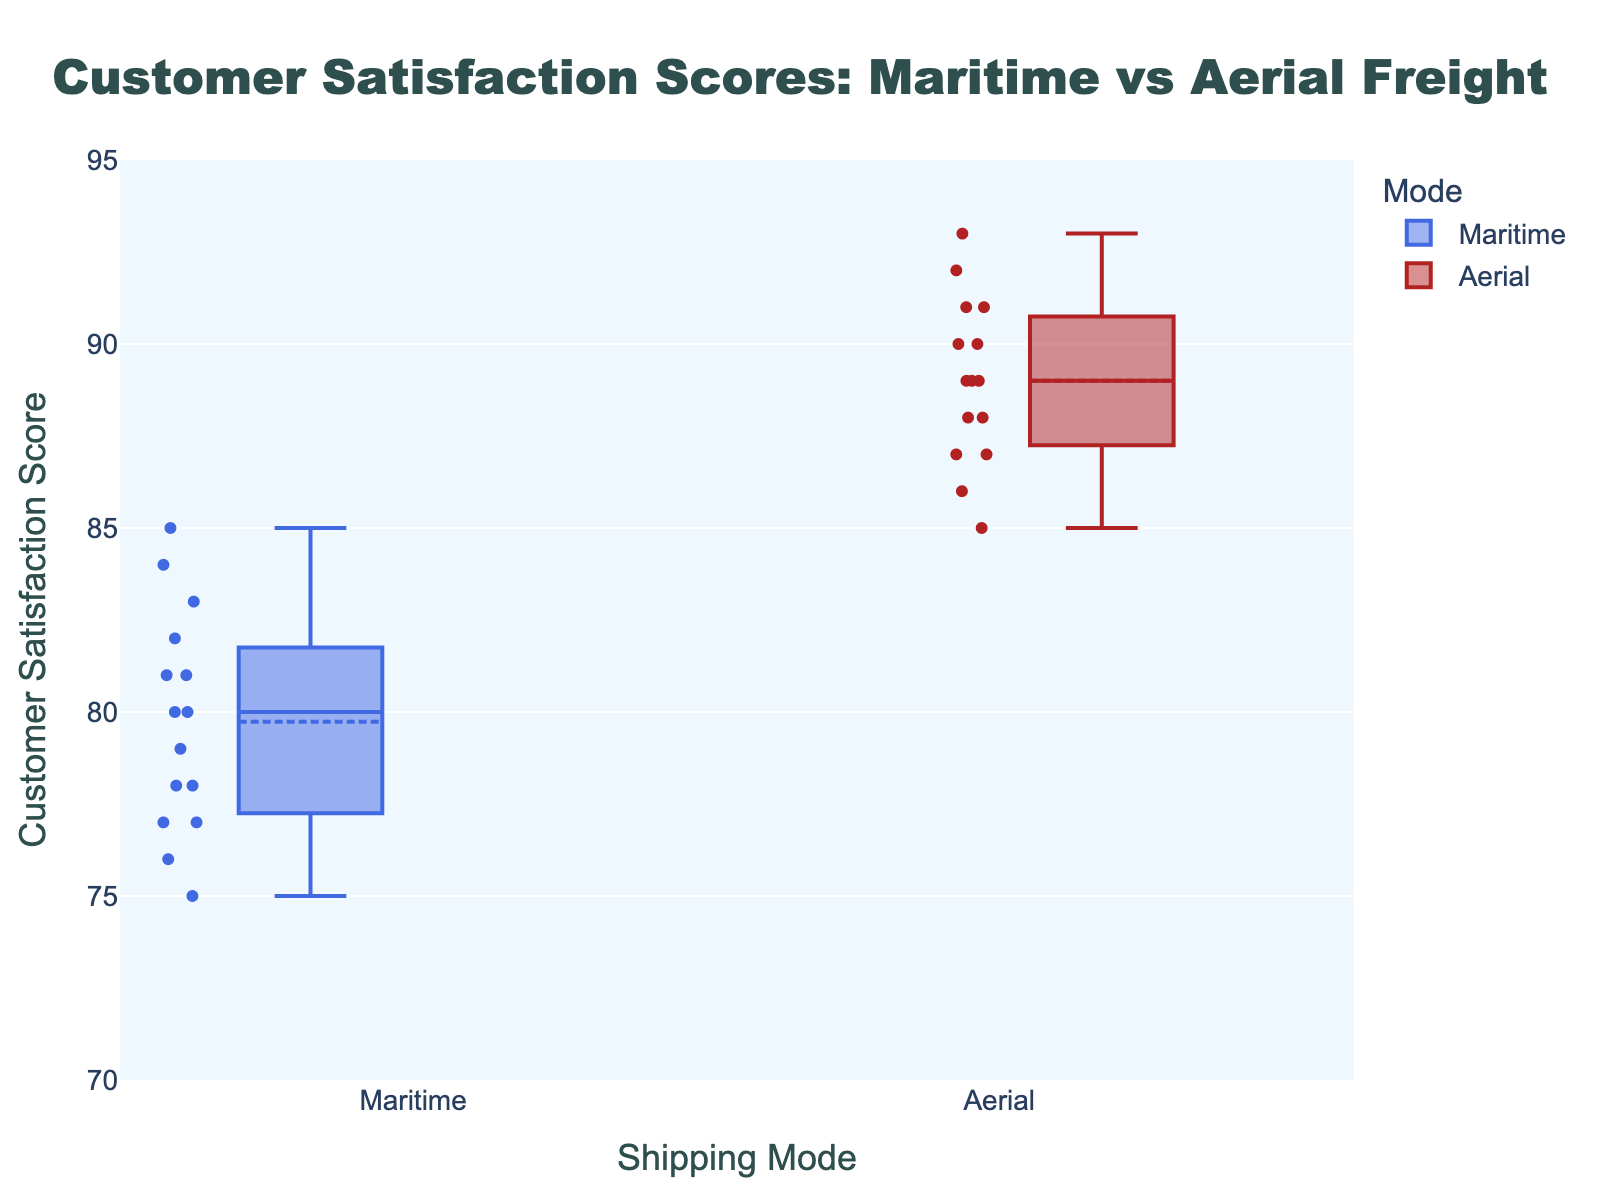what is the title of the figure? The title of the figure is located at the top center, and it is "Customer Satisfaction Scores: Maritime vs Aerial Freight".
Answer: Customer Satisfaction Scores: Maritime vs Aerial Freight what is the range of the y-axis? The range of the y-axis can be determined by looking at the y-axis labels. It starts at 70 and goes up to 95.
Answer: 70 to 95 Which shipping mode has the highest customer satisfaction score? By examining the highest points in both boxes, the Aerial shipping mode reaches the highest score of 93.
Answer: Aerial What is the median customer satisfaction score for maritime freight? The median is indicated by the middle line in the maritime box plot. By examining the plot, the median for maritime freight is approximately 80.
Answer: 80 Compare the average customer satisfaction scores between maritime and aerial freight services. Which one is higher? The average scores can be inferred from the box mean marks represented by dotted lines in the box plots. The average score for maritime is around 79, while for aerial, it is about 89. Thus, aerial has a higher average score.
Answer: Aerial How does the spread of customer satisfaction scores compare between maritime and aerial freight? The spread can be observed by comparing the lengths of the boxes and whiskers. Maritime has a narrower range and box, indicating less variability compared to aerial freight, which has a wider range and box.
Answer: Maritime has less spread, Aerial has more spread What is the interquartile range (IQR) for maritime freight? The IQR is the range between the first quartile (Q1) and third quartile (Q3). For maritime freight, Q1 is around 77 and Q3 is about 83, so IQR is 83 - 77 = 6.
Answer: 6 How many data points are there for aerial freight? Each dot inside the aerial box plot represents a data point. Counting them gives 15 data points for aerial freight.
Answer: 15 What is the minimum customer satisfaction score for maritime freight? The minimum score is the lowest point in the maritime box plot. The minimum score appears to be 75 for maritime freight.
Answer: 75 Is there any overlap in the customer satisfaction scores between maritime and aerial freight? Overlap can be observed if there are any similar values between the two boxes. Both boxes fall within the 75 to 93 range, indicating an overlap in this range.
Answer: Yes 